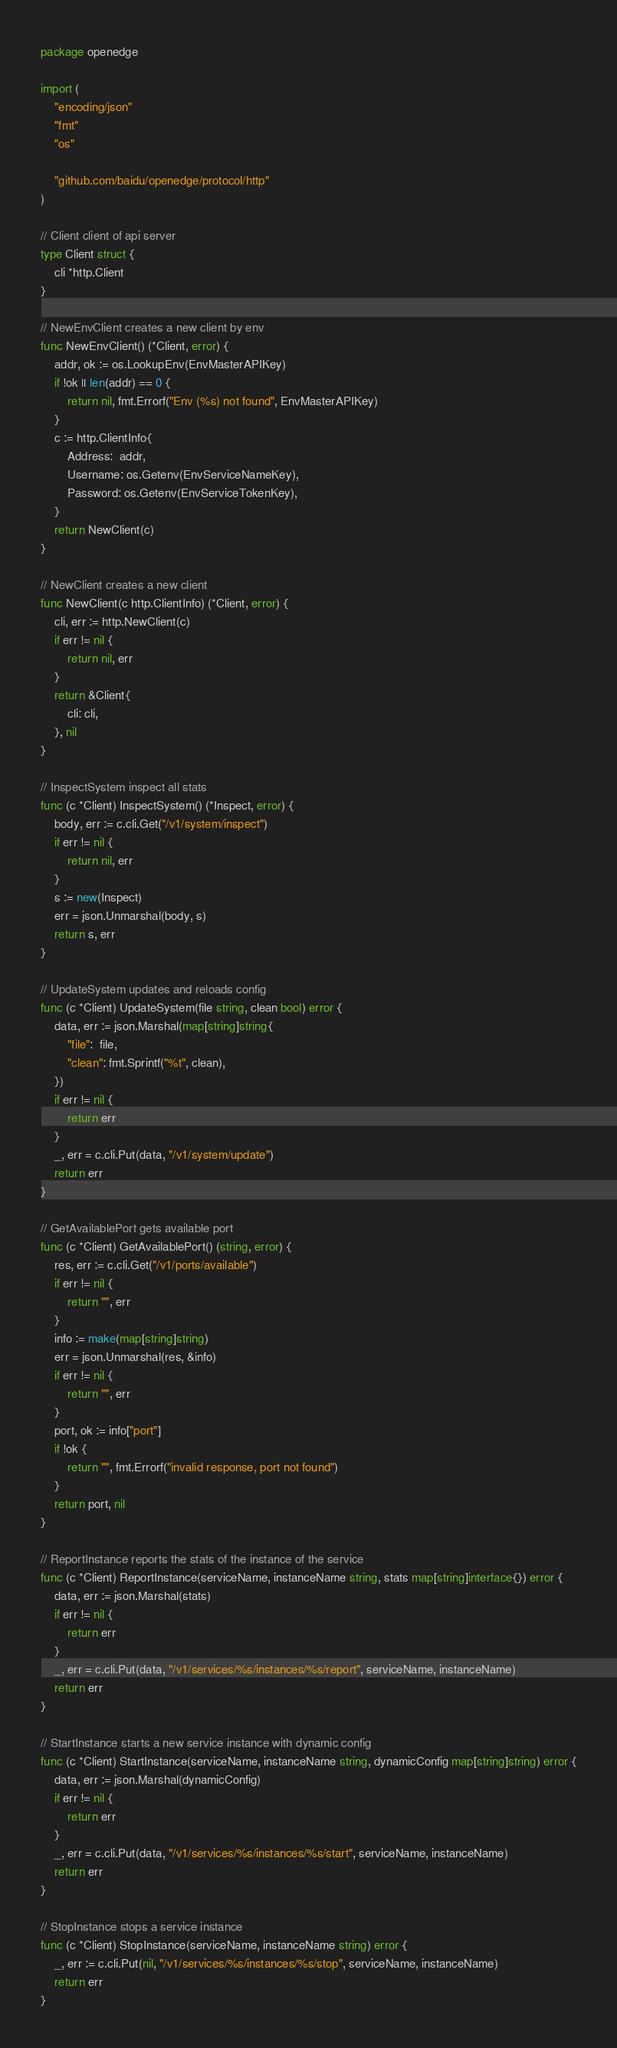Convert code to text. <code><loc_0><loc_0><loc_500><loc_500><_Go_>package openedge

import (
	"encoding/json"
	"fmt"
	"os"

	"github.com/baidu/openedge/protocol/http"
)

// Client client of api server
type Client struct {
	cli *http.Client
}

// NewEnvClient creates a new client by env
func NewEnvClient() (*Client, error) {
	addr, ok := os.LookupEnv(EnvMasterAPIKey)
	if !ok || len(addr) == 0 {
		return nil, fmt.Errorf("Env (%s) not found", EnvMasterAPIKey)
	}
	c := http.ClientInfo{
		Address:  addr,
		Username: os.Getenv(EnvServiceNameKey),
		Password: os.Getenv(EnvServiceTokenKey),
	}
	return NewClient(c)
}

// NewClient creates a new client
func NewClient(c http.ClientInfo) (*Client, error) {
	cli, err := http.NewClient(c)
	if err != nil {
		return nil, err
	}
	return &Client{
		cli: cli,
	}, nil
}

// InspectSystem inspect all stats
func (c *Client) InspectSystem() (*Inspect, error) {
	body, err := c.cli.Get("/v1/system/inspect")
	if err != nil {
		return nil, err
	}
	s := new(Inspect)
	err = json.Unmarshal(body, s)
	return s, err
}

// UpdateSystem updates and reloads config
func (c *Client) UpdateSystem(file string, clean bool) error {
	data, err := json.Marshal(map[string]string{
		"file":  file,
		"clean": fmt.Sprintf("%t", clean),
	})
	if err != nil {
		return err
	}
	_, err = c.cli.Put(data, "/v1/system/update")
	return err
}

// GetAvailablePort gets available port
func (c *Client) GetAvailablePort() (string, error) {
	res, err := c.cli.Get("/v1/ports/available")
	if err != nil {
		return "", err
	}
	info := make(map[string]string)
	err = json.Unmarshal(res, &info)
	if err != nil {
		return "", err
	}
	port, ok := info["port"]
	if !ok {
		return "", fmt.Errorf("invalid response, port not found")
	}
	return port, nil
}

// ReportInstance reports the stats of the instance of the service
func (c *Client) ReportInstance(serviceName, instanceName string, stats map[string]interface{}) error {
	data, err := json.Marshal(stats)
	if err != nil {
		return err
	}
	_, err = c.cli.Put(data, "/v1/services/%s/instances/%s/report", serviceName, instanceName)
	return err
}

// StartInstance starts a new service instance with dynamic config
func (c *Client) StartInstance(serviceName, instanceName string, dynamicConfig map[string]string) error {
	data, err := json.Marshal(dynamicConfig)
	if err != nil {
		return err
	}
	_, err = c.cli.Put(data, "/v1/services/%s/instances/%s/start", serviceName, instanceName)
	return err
}

// StopInstance stops a service instance
func (c *Client) StopInstance(serviceName, instanceName string) error {
	_, err := c.cli.Put(nil, "/v1/services/%s/instances/%s/stop", serviceName, instanceName)
	return err
}
</code> 